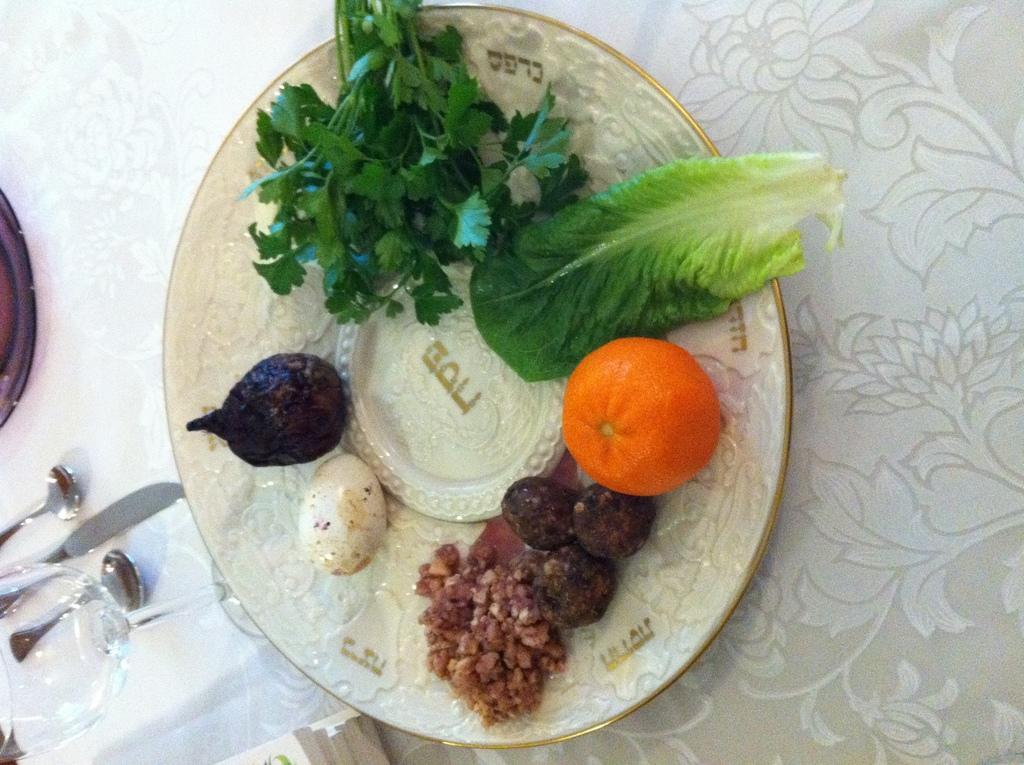Could you give a brief overview of what you see in this image? This image consist of food which is on the plate in the center. On the left side of the plate there are spoons, there is a glass, and a knife. 